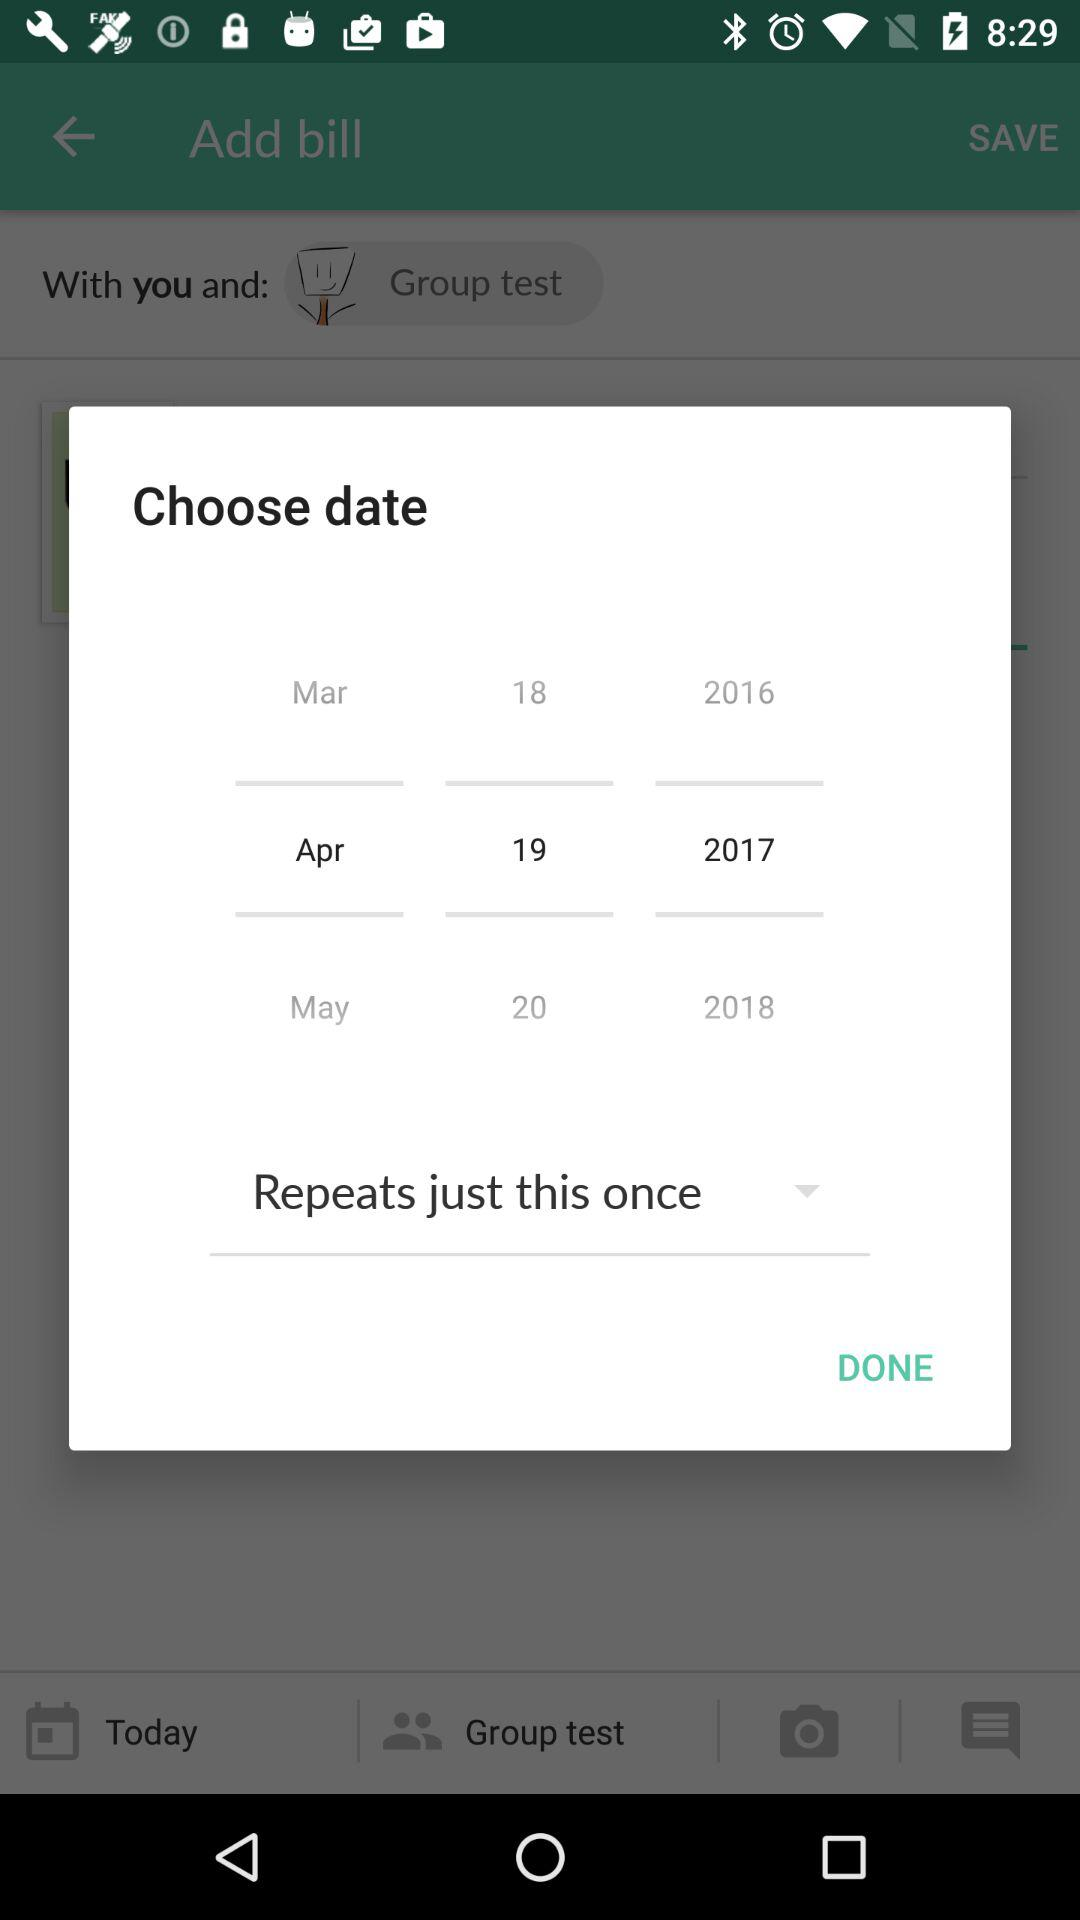Which date is selected? The selected date is April 19, 2017. 